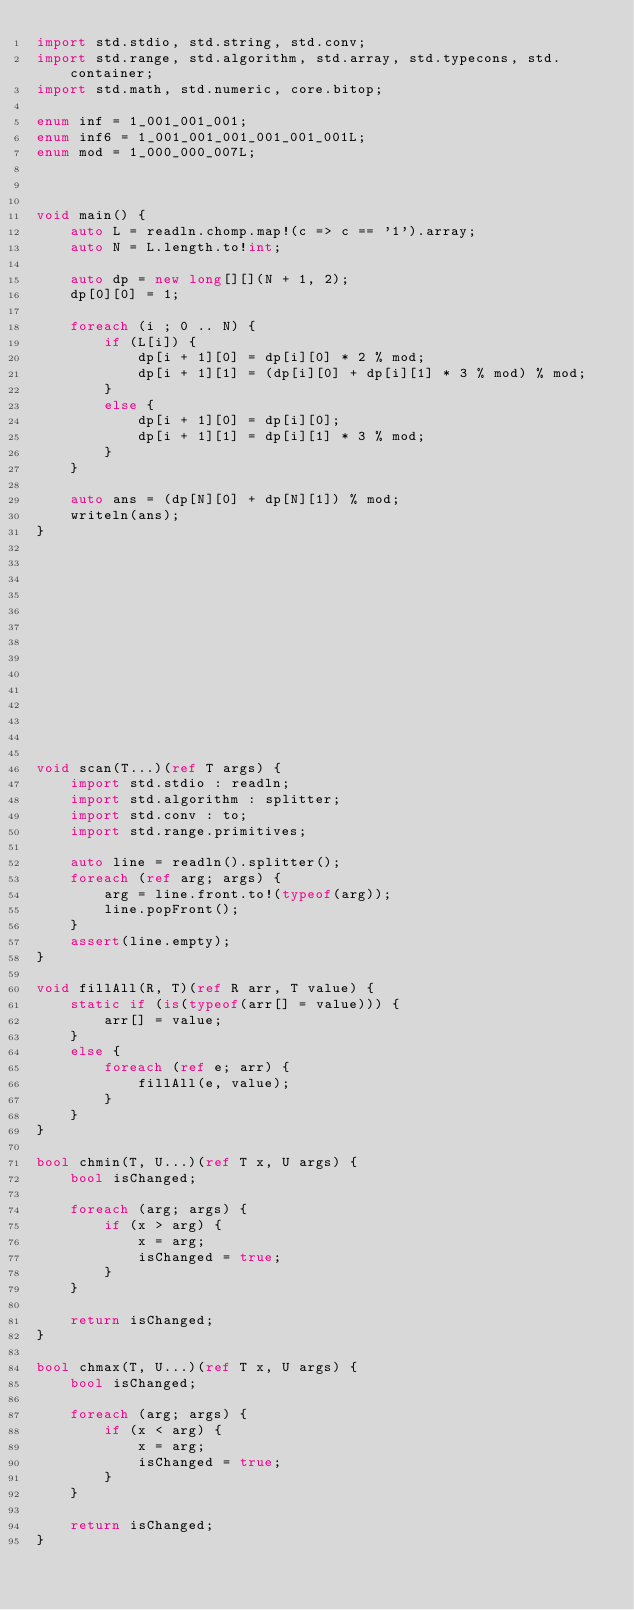Convert code to text. <code><loc_0><loc_0><loc_500><loc_500><_D_>import std.stdio, std.string, std.conv;
import std.range, std.algorithm, std.array, std.typecons, std.container;
import std.math, std.numeric, core.bitop;

enum inf = 1_001_001_001;
enum inf6 = 1_001_001_001_001_001_001L;
enum mod = 1_000_000_007L;



void main() {
    auto L = readln.chomp.map!(c => c == '1').array;
    auto N = L.length.to!int;

    auto dp = new long[][](N + 1, 2);
    dp[0][0] = 1;

    foreach (i ; 0 .. N) {
        if (L[i]) {
            dp[i + 1][0] = dp[i][0] * 2 % mod;
            dp[i + 1][1] = (dp[i][0] + dp[i][1] * 3 % mod) % mod;
        }
        else {
            dp[i + 1][0] = dp[i][0];
            dp[i + 1][1] = dp[i][1] * 3 % mod;
        }
    }

    auto ans = (dp[N][0] + dp[N][1]) % mod;
    writeln(ans);
}














void scan(T...)(ref T args) {
    import std.stdio : readln;
    import std.algorithm : splitter;
    import std.conv : to;
    import std.range.primitives;

    auto line = readln().splitter();
    foreach (ref arg; args) {
        arg = line.front.to!(typeof(arg));
        line.popFront();
    }
    assert(line.empty);
}

void fillAll(R, T)(ref R arr, T value) {
    static if (is(typeof(arr[] = value))) {
        arr[] = value;
    }
    else {
        foreach (ref e; arr) {
            fillAll(e, value);
        }
    }
}

bool chmin(T, U...)(ref T x, U args) {
    bool isChanged;

    foreach (arg; args) {
        if (x > arg) {
            x = arg;
            isChanged = true;
        }
    }

    return isChanged;
}

bool chmax(T, U...)(ref T x, U args) {
    bool isChanged;

    foreach (arg; args) {
        if (x < arg) {
            x = arg;
            isChanged = true;
        }
    }

    return isChanged;
}
</code> 